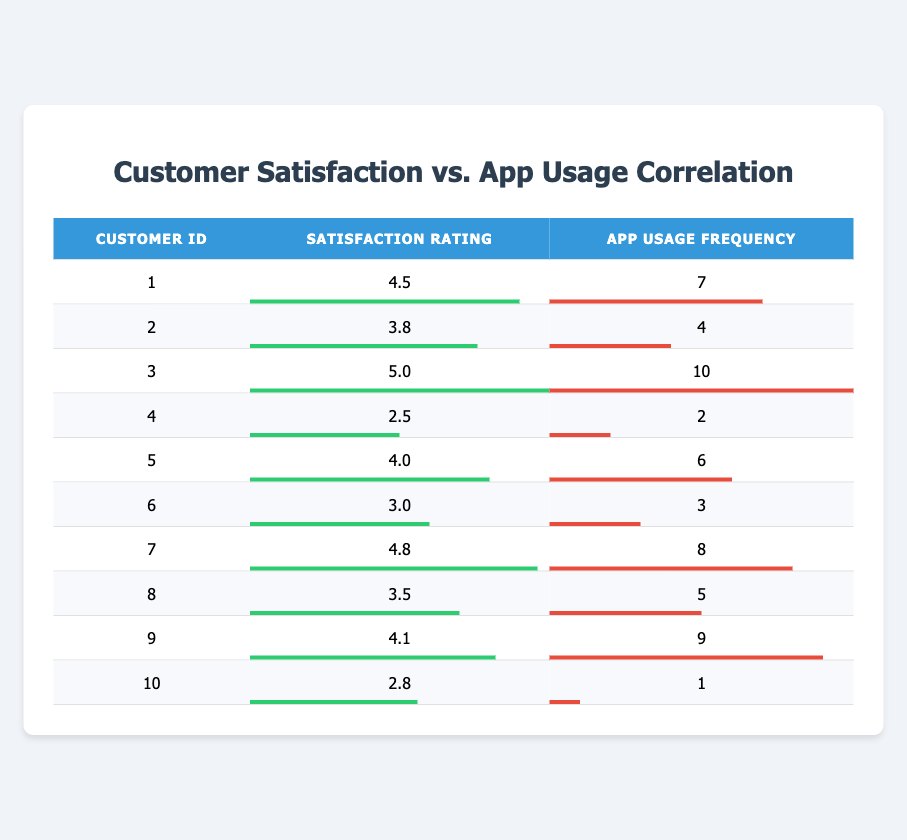What is the highest customer satisfaction rating? The highest satisfaction rating in the table is found by scanning the "Satisfaction Rating" column for the maximum value. The highest value is 5.0, which belongs to Customer ID 3.
Answer: 5.0 What is the app usage frequency of Customer ID 7? The app usage frequency can be found directly by looking at the row for Customer ID 7 in the "App Usage Frequency" column. The value for Customer ID 7 is 8.
Answer: 8 How many customers have a satisfaction rating above 4.0? To find this, we will count the number of ratings in the "Satisfaction Rating" column that are greater than 4.0. Customers with ratings 4.5, 5.0, 4.0, 4.8, and 4.1 meet this criteria, totaling to 5 customers.
Answer: 5 What is the average satisfaction rating of customers who use the app more than 5 times a week? First, we identify those customers from the "App Usage Frequency" column who use the app more than 5 times. These customers are IDs 1, 3, 5, 7, 9. Their satisfaction ratings are 4.5, 5.0, 4.0, 4.8, 4.1 respectively. To average, we sum these ratings: (4.5 + 5.0 + 4.0 + 4.8 + 4.1) = 22.4, and divide by the number of customers (5), resulting in an average of 22.4/5 = 4.48.
Answer: 4.48 Is the satisfaction rating of Customer ID 4 higher than 3.0? Checking the "Satisfaction Rating" for Customer ID 4, we find it to be 2.5, which is less than 3.0. Thus, the statement is false.
Answer: No What is the difference between the highest and lowest app usage frequencies? The lowest app usage frequency is 1 (Customer ID 10), and the highest is 10 (Customer ID 3). We find the difference by subtracting the lowest from the highest: 10 - 1 = 9.
Answer: 9 How many customers have an app usage frequency of less than 4? We check the "App Usage Frequency" column for values under 4 and find that Customers ID 4, 6, and 10 meet this criterion. This totals to 3 customers.
Answer: 3 Does Customer ID 2 have both a satisfaction rating and app usage frequency above 4? For Customer ID 2, the satisfaction rating is 3.8 and the app usage frequency is 4. Since the satisfaction rating is not above 4, the overall statement is false.
Answer: No 